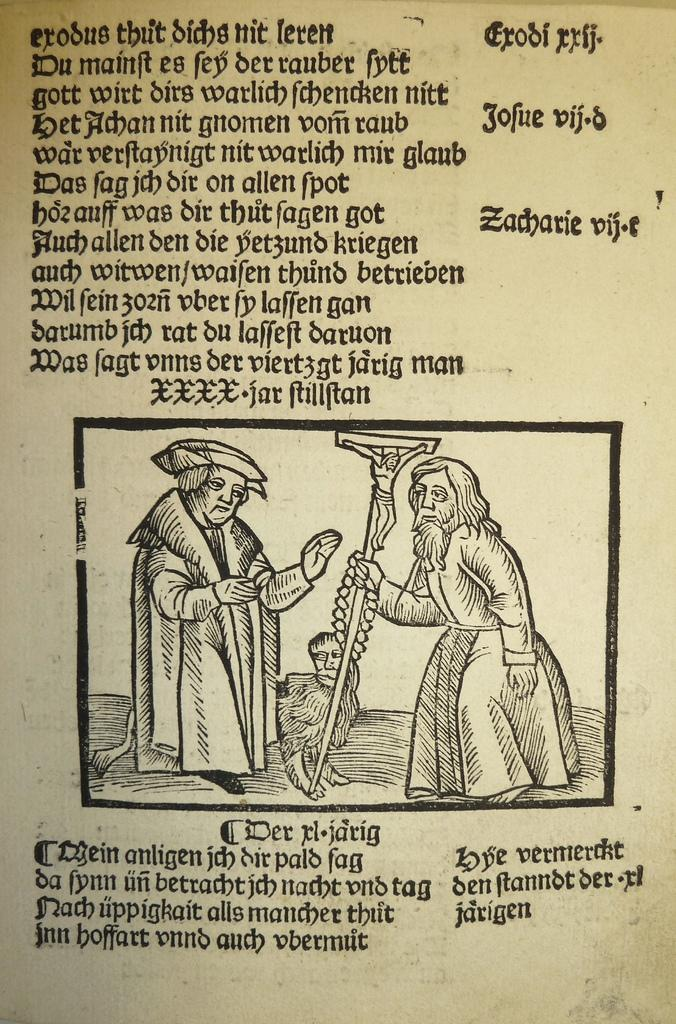What is the main object in the image? There is a paper with printed text in the image. What can be inferred about the language of the text? The text is in a different language. How many people are in the image? There are two men standing in the image. What might be the context of the image? The image might be taken from a textbook. What type of cloud can be seen in the image? There are no clouds present in the image; it features a paper with printed text and two men. 